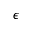<formula> <loc_0><loc_0><loc_500><loc_500>\epsilon</formula> 